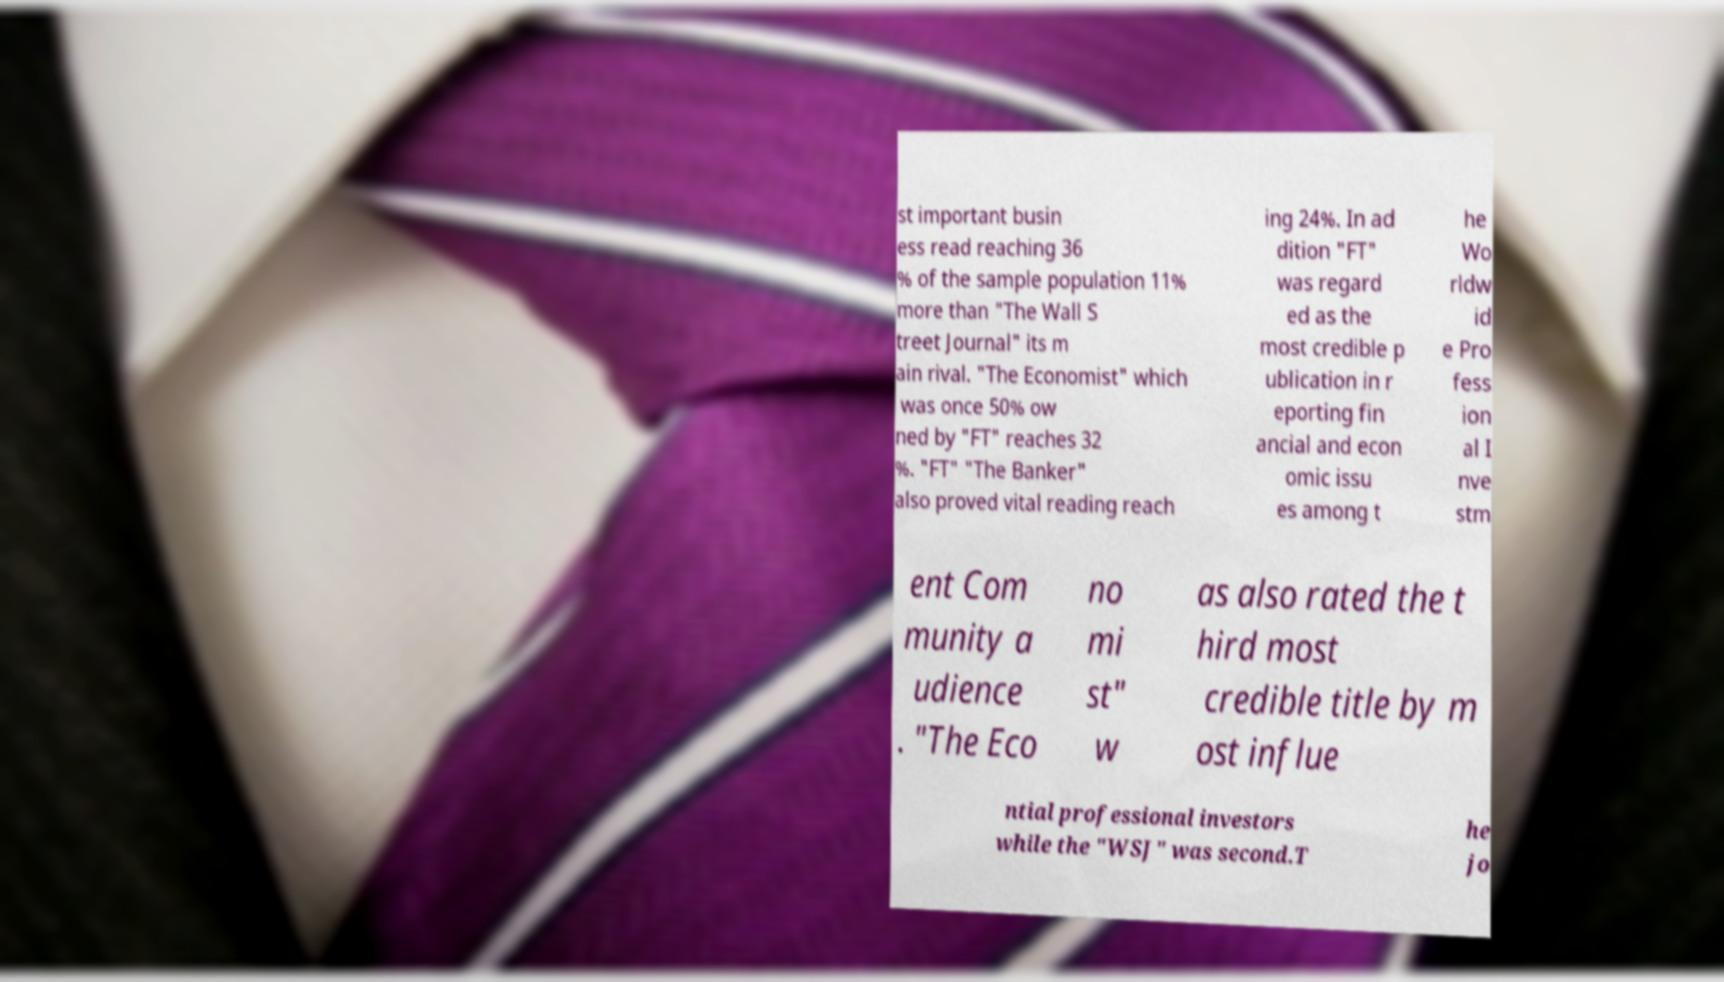Can you accurately transcribe the text from the provided image for me? st important busin ess read reaching 36 % of the sample population 11% more than "The Wall S treet Journal" its m ain rival. "The Economist" which was once 50% ow ned by "FT" reaches 32 %. "FT" "The Banker" also proved vital reading reach ing 24%. In ad dition "FT" was regard ed as the most credible p ublication in r eporting fin ancial and econ omic issu es among t he Wo rldw id e Pro fess ion al I nve stm ent Com munity a udience . "The Eco no mi st" w as also rated the t hird most credible title by m ost influe ntial professional investors while the "WSJ" was second.T he jo 